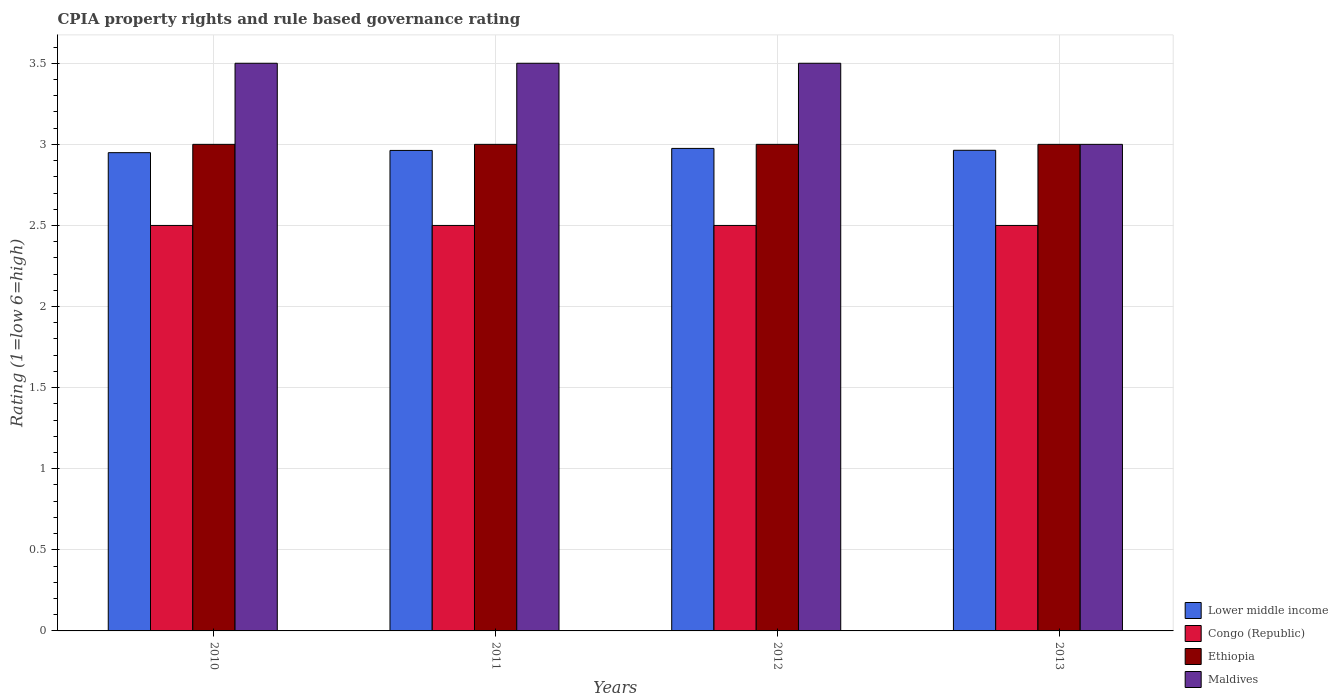How many groups of bars are there?
Offer a very short reply. 4. How many bars are there on the 2nd tick from the left?
Ensure brevity in your answer.  4. How many bars are there on the 4th tick from the right?
Offer a terse response. 4. What is the CPIA rating in Congo (Republic) in 2010?
Your answer should be very brief. 2.5. Across all years, what is the maximum CPIA rating in Lower middle income?
Your answer should be very brief. 2.98. Across all years, what is the minimum CPIA rating in Congo (Republic)?
Ensure brevity in your answer.  2.5. What is the difference between the CPIA rating in Ethiopia in 2010 and that in 2011?
Keep it short and to the point. 0. What is the difference between the CPIA rating in Lower middle income in 2012 and the CPIA rating in Ethiopia in 2013?
Your response must be concise. -0.02. What is the average CPIA rating in Maldives per year?
Your answer should be very brief. 3.38. In the year 2011, what is the difference between the CPIA rating in Maldives and CPIA rating in Congo (Republic)?
Give a very brief answer. 1. What is the ratio of the CPIA rating in Congo (Republic) in 2012 to that in 2013?
Offer a very short reply. 1. Is the difference between the CPIA rating in Maldives in 2010 and 2012 greater than the difference between the CPIA rating in Congo (Republic) in 2010 and 2012?
Your answer should be compact. No. What is the difference between the highest and the lowest CPIA rating in Ethiopia?
Offer a very short reply. 0. In how many years, is the CPIA rating in Lower middle income greater than the average CPIA rating in Lower middle income taken over all years?
Your answer should be very brief. 3. Is it the case that in every year, the sum of the CPIA rating in Lower middle income and CPIA rating in Congo (Republic) is greater than the sum of CPIA rating in Ethiopia and CPIA rating in Maldives?
Offer a terse response. Yes. What does the 4th bar from the left in 2013 represents?
Your answer should be compact. Maldives. What does the 1st bar from the right in 2011 represents?
Offer a terse response. Maldives. Is it the case that in every year, the sum of the CPIA rating in Congo (Republic) and CPIA rating in Ethiopia is greater than the CPIA rating in Maldives?
Offer a terse response. Yes. How many bars are there?
Ensure brevity in your answer.  16. Are all the bars in the graph horizontal?
Give a very brief answer. No. How many years are there in the graph?
Give a very brief answer. 4. Does the graph contain any zero values?
Your response must be concise. No. Where does the legend appear in the graph?
Provide a short and direct response. Bottom right. How many legend labels are there?
Give a very brief answer. 4. How are the legend labels stacked?
Ensure brevity in your answer.  Vertical. What is the title of the graph?
Provide a short and direct response. CPIA property rights and rule based governance rating. Does "Afghanistan" appear as one of the legend labels in the graph?
Your answer should be compact. No. What is the Rating (1=low 6=high) in Lower middle income in 2010?
Your answer should be very brief. 2.95. What is the Rating (1=low 6=high) of Ethiopia in 2010?
Provide a short and direct response. 3. What is the Rating (1=low 6=high) of Maldives in 2010?
Provide a succinct answer. 3.5. What is the Rating (1=low 6=high) in Lower middle income in 2011?
Your response must be concise. 2.96. What is the Rating (1=low 6=high) of Maldives in 2011?
Give a very brief answer. 3.5. What is the Rating (1=low 6=high) of Lower middle income in 2012?
Keep it short and to the point. 2.98. What is the Rating (1=low 6=high) in Maldives in 2012?
Offer a terse response. 3.5. What is the Rating (1=low 6=high) in Lower middle income in 2013?
Offer a very short reply. 2.96. What is the Rating (1=low 6=high) in Ethiopia in 2013?
Ensure brevity in your answer.  3. What is the Rating (1=low 6=high) in Maldives in 2013?
Provide a succinct answer. 3. Across all years, what is the maximum Rating (1=low 6=high) in Lower middle income?
Your answer should be very brief. 2.98. Across all years, what is the maximum Rating (1=low 6=high) in Congo (Republic)?
Your answer should be compact. 2.5. Across all years, what is the maximum Rating (1=low 6=high) of Maldives?
Provide a succinct answer. 3.5. Across all years, what is the minimum Rating (1=low 6=high) of Lower middle income?
Ensure brevity in your answer.  2.95. Across all years, what is the minimum Rating (1=low 6=high) of Ethiopia?
Keep it short and to the point. 3. What is the total Rating (1=low 6=high) in Lower middle income in the graph?
Your answer should be very brief. 11.85. What is the total Rating (1=low 6=high) in Ethiopia in the graph?
Your answer should be compact. 12. What is the total Rating (1=low 6=high) in Maldives in the graph?
Make the answer very short. 13.5. What is the difference between the Rating (1=low 6=high) in Lower middle income in 2010 and that in 2011?
Offer a terse response. -0.01. What is the difference between the Rating (1=low 6=high) in Congo (Republic) in 2010 and that in 2011?
Your answer should be very brief. 0. What is the difference between the Rating (1=low 6=high) in Ethiopia in 2010 and that in 2011?
Give a very brief answer. 0. What is the difference between the Rating (1=low 6=high) in Maldives in 2010 and that in 2011?
Your answer should be compact. 0. What is the difference between the Rating (1=low 6=high) in Lower middle income in 2010 and that in 2012?
Ensure brevity in your answer.  -0.03. What is the difference between the Rating (1=low 6=high) of Ethiopia in 2010 and that in 2012?
Your answer should be compact. 0. What is the difference between the Rating (1=low 6=high) in Maldives in 2010 and that in 2012?
Provide a short and direct response. 0. What is the difference between the Rating (1=low 6=high) of Lower middle income in 2010 and that in 2013?
Ensure brevity in your answer.  -0.01. What is the difference between the Rating (1=low 6=high) in Ethiopia in 2010 and that in 2013?
Ensure brevity in your answer.  0. What is the difference between the Rating (1=low 6=high) in Lower middle income in 2011 and that in 2012?
Your answer should be very brief. -0.01. What is the difference between the Rating (1=low 6=high) of Congo (Republic) in 2011 and that in 2012?
Keep it short and to the point. 0. What is the difference between the Rating (1=low 6=high) of Lower middle income in 2011 and that in 2013?
Your answer should be very brief. -0. What is the difference between the Rating (1=low 6=high) of Congo (Republic) in 2011 and that in 2013?
Offer a very short reply. 0. What is the difference between the Rating (1=low 6=high) of Lower middle income in 2012 and that in 2013?
Provide a short and direct response. 0.01. What is the difference between the Rating (1=low 6=high) of Ethiopia in 2012 and that in 2013?
Give a very brief answer. 0. What is the difference between the Rating (1=low 6=high) of Maldives in 2012 and that in 2013?
Ensure brevity in your answer.  0.5. What is the difference between the Rating (1=low 6=high) in Lower middle income in 2010 and the Rating (1=low 6=high) in Congo (Republic) in 2011?
Ensure brevity in your answer.  0.45. What is the difference between the Rating (1=low 6=high) in Lower middle income in 2010 and the Rating (1=low 6=high) in Ethiopia in 2011?
Provide a short and direct response. -0.05. What is the difference between the Rating (1=low 6=high) of Lower middle income in 2010 and the Rating (1=low 6=high) of Maldives in 2011?
Your response must be concise. -0.55. What is the difference between the Rating (1=low 6=high) in Congo (Republic) in 2010 and the Rating (1=low 6=high) in Ethiopia in 2011?
Provide a short and direct response. -0.5. What is the difference between the Rating (1=low 6=high) in Congo (Republic) in 2010 and the Rating (1=low 6=high) in Maldives in 2011?
Make the answer very short. -1. What is the difference between the Rating (1=low 6=high) of Ethiopia in 2010 and the Rating (1=low 6=high) of Maldives in 2011?
Your answer should be very brief. -0.5. What is the difference between the Rating (1=low 6=high) of Lower middle income in 2010 and the Rating (1=low 6=high) of Congo (Republic) in 2012?
Keep it short and to the point. 0.45. What is the difference between the Rating (1=low 6=high) in Lower middle income in 2010 and the Rating (1=low 6=high) in Ethiopia in 2012?
Your answer should be very brief. -0.05. What is the difference between the Rating (1=low 6=high) of Lower middle income in 2010 and the Rating (1=low 6=high) of Maldives in 2012?
Keep it short and to the point. -0.55. What is the difference between the Rating (1=low 6=high) in Congo (Republic) in 2010 and the Rating (1=low 6=high) in Ethiopia in 2012?
Give a very brief answer. -0.5. What is the difference between the Rating (1=low 6=high) of Congo (Republic) in 2010 and the Rating (1=low 6=high) of Maldives in 2012?
Ensure brevity in your answer.  -1. What is the difference between the Rating (1=low 6=high) in Lower middle income in 2010 and the Rating (1=low 6=high) in Congo (Republic) in 2013?
Keep it short and to the point. 0.45. What is the difference between the Rating (1=low 6=high) of Lower middle income in 2010 and the Rating (1=low 6=high) of Ethiopia in 2013?
Keep it short and to the point. -0.05. What is the difference between the Rating (1=low 6=high) in Lower middle income in 2010 and the Rating (1=low 6=high) in Maldives in 2013?
Your answer should be compact. -0.05. What is the difference between the Rating (1=low 6=high) in Congo (Republic) in 2010 and the Rating (1=low 6=high) in Ethiopia in 2013?
Offer a very short reply. -0.5. What is the difference between the Rating (1=low 6=high) of Congo (Republic) in 2010 and the Rating (1=low 6=high) of Maldives in 2013?
Your response must be concise. -0.5. What is the difference between the Rating (1=low 6=high) of Ethiopia in 2010 and the Rating (1=low 6=high) of Maldives in 2013?
Give a very brief answer. 0. What is the difference between the Rating (1=low 6=high) of Lower middle income in 2011 and the Rating (1=low 6=high) of Congo (Republic) in 2012?
Offer a terse response. 0.46. What is the difference between the Rating (1=low 6=high) of Lower middle income in 2011 and the Rating (1=low 6=high) of Ethiopia in 2012?
Your response must be concise. -0.04. What is the difference between the Rating (1=low 6=high) in Lower middle income in 2011 and the Rating (1=low 6=high) in Maldives in 2012?
Provide a short and direct response. -0.54. What is the difference between the Rating (1=low 6=high) in Congo (Republic) in 2011 and the Rating (1=low 6=high) in Ethiopia in 2012?
Offer a very short reply. -0.5. What is the difference between the Rating (1=low 6=high) of Congo (Republic) in 2011 and the Rating (1=low 6=high) of Maldives in 2012?
Your answer should be very brief. -1. What is the difference between the Rating (1=low 6=high) of Lower middle income in 2011 and the Rating (1=low 6=high) of Congo (Republic) in 2013?
Provide a short and direct response. 0.46. What is the difference between the Rating (1=low 6=high) of Lower middle income in 2011 and the Rating (1=low 6=high) of Ethiopia in 2013?
Your response must be concise. -0.04. What is the difference between the Rating (1=low 6=high) in Lower middle income in 2011 and the Rating (1=low 6=high) in Maldives in 2013?
Keep it short and to the point. -0.04. What is the difference between the Rating (1=low 6=high) in Lower middle income in 2012 and the Rating (1=low 6=high) in Congo (Republic) in 2013?
Provide a short and direct response. 0.47. What is the difference between the Rating (1=low 6=high) of Lower middle income in 2012 and the Rating (1=low 6=high) of Ethiopia in 2013?
Keep it short and to the point. -0.03. What is the difference between the Rating (1=low 6=high) of Lower middle income in 2012 and the Rating (1=low 6=high) of Maldives in 2013?
Your answer should be compact. -0.03. What is the difference between the Rating (1=low 6=high) of Congo (Republic) in 2012 and the Rating (1=low 6=high) of Ethiopia in 2013?
Your answer should be very brief. -0.5. What is the difference between the Rating (1=low 6=high) in Ethiopia in 2012 and the Rating (1=low 6=high) in Maldives in 2013?
Provide a succinct answer. 0. What is the average Rating (1=low 6=high) in Lower middle income per year?
Offer a very short reply. 2.96. What is the average Rating (1=low 6=high) of Congo (Republic) per year?
Your answer should be compact. 2.5. What is the average Rating (1=low 6=high) of Ethiopia per year?
Make the answer very short. 3. What is the average Rating (1=low 6=high) of Maldives per year?
Your answer should be very brief. 3.38. In the year 2010, what is the difference between the Rating (1=low 6=high) of Lower middle income and Rating (1=low 6=high) of Congo (Republic)?
Your answer should be very brief. 0.45. In the year 2010, what is the difference between the Rating (1=low 6=high) of Lower middle income and Rating (1=low 6=high) of Ethiopia?
Offer a very short reply. -0.05. In the year 2010, what is the difference between the Rating (1=low 6=high) in Lower middle income and Rating (1=low 6=high) in Maldives?
Your answer should be compact. -0.55. In the year 2010, what is the difference between the Rating (1=low 6=high) of Congo (Republic) and Rating (1=low 6=high) of Ethiopia?
Offer a very short reply. -0.5. In the year 2010, what is the difference between the Rating (1=low 6=high) of Congo (Republic) and Rating (1=low 6=high) of Maldives?
Provide a short and direct response. -1. In the year 2010, what is the difference between the Rating (1=low 6=high) in Ethiopia and Rating (1=low 6=high) in Maldives?
Your answer should be very brief. -0.5. In the year 2011, what is the difference between the Rating (1=low 6=high) of Lower middle income and Rating (1=low 6=high) of Congo (Republic)?
Provide a short and direct response. 0.46. In the year 2011, what is the difference between the Rating (1=low 6=high) of Lower middle income and Rating (1=low 6=high) of Ethiopia?
Offer a very short reply. -0.04. In the year 2011, what is the difference between the Rating (1=low 6=high) of Lower middle income and Rating (1=low 6=high) of Maldives?
Your answer should be very brief. -0.54. In the year 2011, what is the difference between the Rating (1=low 6=high) of Congo (Republic) and Rating (1=low 6=high) of Maldives?
Provide a succinct answer. -1. In the year 2011, what is the difference between the Rating (1=low 6=high) of Ethiopia and Rating (1=low 6=high) of Maldives?
Keep it short and to the point. -0.5. In the year 2012, what is the difference between the Rating (1=low 6=high) in Lower middle income and Rating (1=low 6=high) in Congo (Republic)?
Offer a very short reply. 0.47. In the year 2012, what is the difference between the Rating (1=low 6=high) in Lower middle income and Rating (1=low 6=high) in Ethiopia?
Make the answer very short. -0.03. In the year 2012, what is the difference between the Rating (1=low 6=high) in Lower middle income and Rating (1=low 6=high) in Maldives?
Provide a succinct answer. -0.53. In the year 2012, what is the difference between the Rating (1=low 6=high) of Congo (Republic) and Rating (1=low 6=high) of Ethiopia?
Make the answer very short. -0.5. In the year 2012, what is the difference between the Rating (1=low 6=high) in Congo (Republic) and Rating (1=low 6=high) in Maldives?
Your answer should be very brief. -1. In the year 2013, what is the difference between the Rating (1=low 6=high) of Lower middle income and Rating (1=low 6=high) of Congo (Republic)?
Ensure brevity in your answer.  0.46. In the year 2013, what is the difference between the Rating (1=low 6=high) of Lower middle income and Rating (1=low 6=high) of Ethiopia?
Make the answer very short. -0.04. In the year 2013, what is the difference between the Rating (1=low 6=high) of Lower middle income and Rating (1=low 6=high) of Maldives?
Your response must be concise. -0.04. In the year 2013, what is the difference between the Rating (1=low 6=high) in Congo (Republic) and Rating (1=low 6=high) in Ethiopia?
Your answer should be compact. -0.5. What is the ratio of the Rating (1=low 6=high) of Lower middle income in 2010 to that in 2011?
Your answer should be compact. 1. What is the ratio of the Rating (1=low 6=high) of Congo (Republic) in 2010 to that in 2011?
Ensure brevity in your answer.  1. What is the ratio of the Rating (1=low 6=high) in Ethiopia in 2010 to that in 2011?
Keep it short and to the point. 1. What is the ratio of the Rating (1=low 6=high) in Congo (Republic) in 2010 to that in 2012?
Your answer should be compact. 1. What is the ratio of the Rating (1=low 6=high) of Ethiopia in 2010 to that in 2012?
Your answer should be very brief. 1. What is the ratio of the Rating (1=low 6=high) in Congo (Republic) in 2010 to that in 2013?
Provide a short and direct response. 1. What is the ratio of the Rating (1=low 6=high) of Lower middle income in 2011 to that in 2012?
Your response must be concise. 1. What is the ratio of the Rating (1=low 6=high) of Congo (Republic) in 2011 to that in 2013?
Provide a succinct answer. 1. What is the ratio of the Rating (1=low 6=high) of Ethiopia in 2011 to that in 2013?
Provide a short and direct response. 1. What is the ratio of the Rating (1=low 6=high) in Maldives in 2011 to that in 2013?
Provide a short and direct response. 1.17. What is the ratio of the Rating (1=low 6=high) of Lower middle income in 2012 to that in 2013?
Your answer should be compact. 1. What is the difference between the highest and the second highest Rating (1=low 6=high) in Lower middle income?
Your answer should be very brief. 0.01. What is the difference between the highest and the second highest Rating (1=low 6=high) of Congo (Republic)?
Offer a very short reply. 0. What is the difference between the highest and the second highest Rating (1=low 6=high) of Maldives?
Keep it short and to the point. 0. What is the difference between the highest and the lowest Rating (1=low 6=high) of Lower middle income?
Your answer should be compact. 0.03. What is the difference between the highest and the lowest Rating (1=low 6=high) of Ethiopia?
Ensure brevity in your answer.  0. What is the difference between the highest and the lowest Rating (1=low 6=high) of Maldives?
Provide a succinct answer. 0.5. 